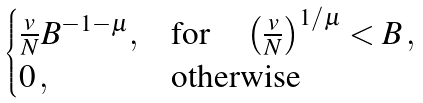<formula> <loc_0><loc_0><loc_500><loc_500>\begin{cases} \frac { v } { N } B ^ { - 1 - \mu } , & \text {for} \quad \left ( \frac { v } { N } \right ) ^ { 1 / \mu } < B \, , \\ 0 \, , \quad & \text {otherwise} \end{cases}</formula> 